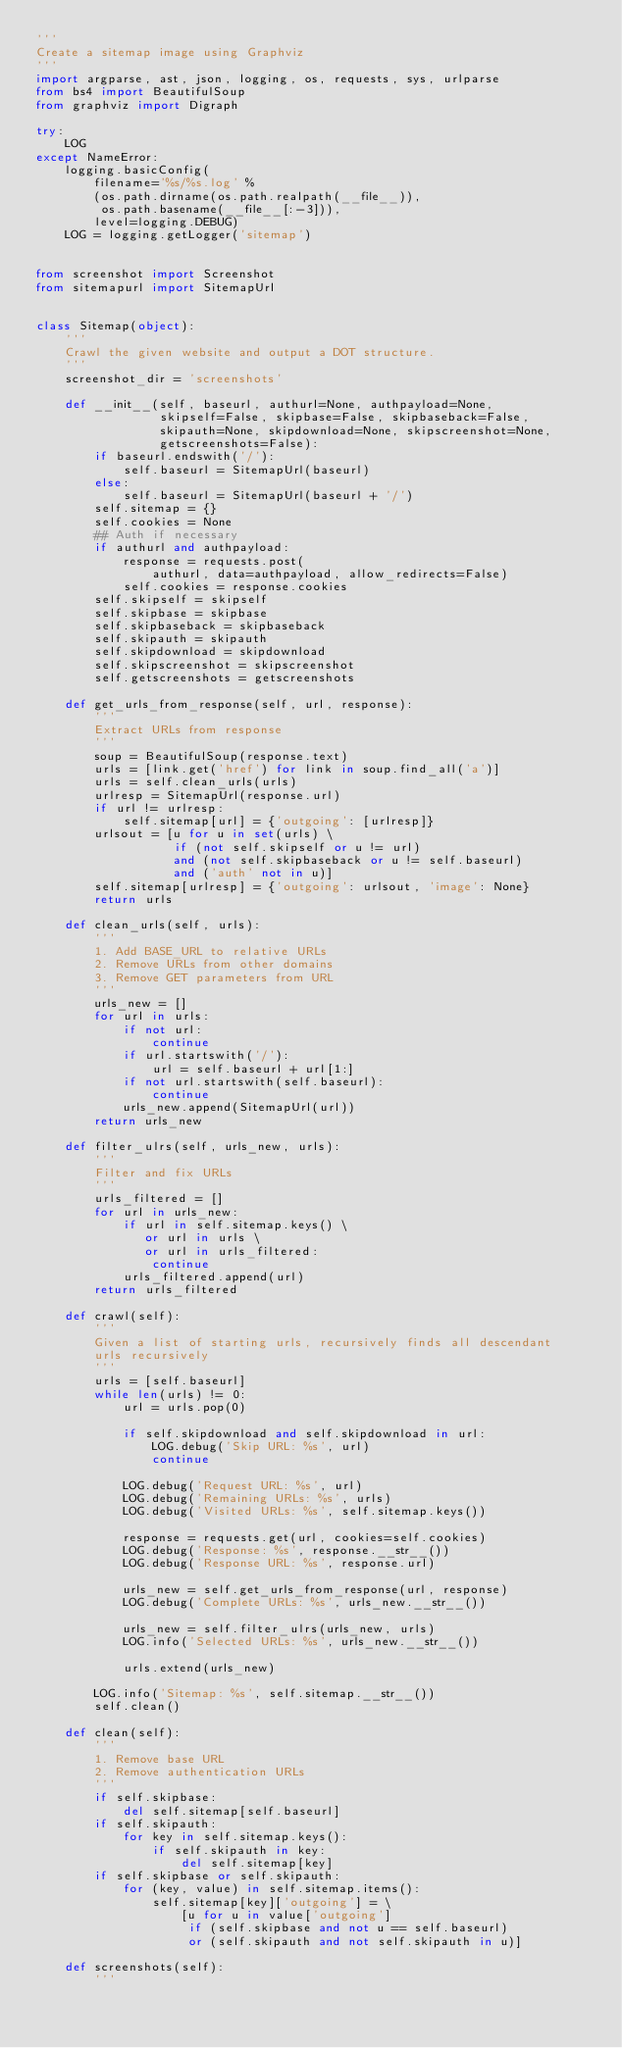Convert code to text. <code><loc_0><loc_0><loc_500><loc_500><_Python_>'''
Create a sitemap image using Graphviz
'''
import argparse, ast, json, logging, os, requests, sys, urlparse
from bs4 import BeautifulSoup
from graphviz import Digraph

try:
    LOG
except NameError:
    logging.basicConfig(
        filename='%s/%s.log' %
        (os.path.dirname(os.path.realpath(__file__)),
         os.path.basename(__file__[:-3])),
        level=logging.DEBUG)
    LOG = logging.getLogger('sitemap')


from screenshot import Screenshot
from sitemapurl import SitemapUrl


class Sitemap(object):
    '''
    Crawl the given website and output a DOT structure.
    '''
    screenshot_dir = 'screenshots'

    def __init__(self, baseurl, authurl=None, authpayload=None,
                 skipself=False, skipbase=False, skipbaseback=False,
                 skipauth=None, skipdownload=None, skipscreenshot=None,
                 getscreenshots=False):
        if baseurl.endswith('/'):
            self.baseurl = SitemapUrl(baseurl)
        else:
            self.baseurl = SitemapUrl(baseurl + '/')
        self.sitemap = {}
        self.cookies = None
        ## Auth if necessary
        if authurl and authpayload:
            response = requests.post(
                authurl, data=authpayload, allow_redirects=False)
            self.cookies = response.cookies
        self.skipself = skipself
        self.skipbase = skipbase
        self.skipbaseback = skipbaseback
        self.skipauth = skipauth
        self.skipdownload = skipdownload
        self.skipscreenshot = skipscreenshot
        self.getscreenshots = getscreenshots

    def get_urls_from_response(self, url, response):
        '''
        Extract URLs from response
        '''
        soup = BeautifulSoup(response.text)
        urls = [link.get('href') for link in soup.find_all('a')]
        urls = self.clean_urls(urls)
        urlresp = SitemapUrl(response.url)
        if url != urlresp:
            self.sitemap[url] = {'outgoing': [urlresp]}
        urlsout = [u for u in set(urls) \
                   if (not self.skipself or u != url)
                   and (not self.skipbaseback or u != self.baseurl)
                   and ('auth' not in u)]
        self.sitemap[urlresp] = {'outgoing': urlsout, 'image': None}
        return urls

    def clean_urls(self, urls):
        '''
        1. Add BASE_URL to relative URLs
        2. Remove URLs from other domains
        3. Remove GET parameters from URL
        '''
        urls_new = []
        for url in urls:
            if not url:
                continue
            if url.startswith('/'):
                url = self.baseurl + url[1:]
            if not url.startswith(self.baseurl):
                continue
            urls_new.append(SitemapUrl(url))
        return urls_new

    def filter_ulrs(self, urls_new, urls):
        '''
        Filter and fix URLs
        '''
        urls_filtered = []
        for url in urls_new:
            if url in self.sitemap.keys() \
               or url in urls \
               or url in urls_filtered:
                continue
            urls_filtered.append(url)
        return urls_filtered

    def crawl(self):
        '''
        Given a list of starting urls, recursively finds all descendant
        urls recursively
        '''
        urls = [self.baseurl]
        while len(urls) != 0:
            url = urls.pop(0)

            if self.skipdownload and self.skipdownload in url:
                LOG.debug('Skip URL: %s', url)
                continue

            LOG.debug('Request URL: %s', url)
            LOG.debug('Remaining URLs: %s', urls)
            LOG.debug('Visited URLs: %s', self.sitemap.keys())

            response = requests.get(url, cookies=self.cookies)
            LOG.debug('Response: %s', response.__str__())
            LOG.debug('Response URL: %s', response.url)

            urls_new = self.get_urls_from_response(url, response)
            LOG.debug('Complete URLs: %s', urls_new.__str__())

            urls_new = self.filter_ulrs(urls_new, urls)
            LOG.info('Selected URLs: %s', urls_new.__str__())

            urls.extend(urls_new)

        LOG.info('Sitemap: %s', self.sitemap.__str__())
        self.clean()

    def clean(self):
        '''
        1. Remove base URL
        2. Remove authentication URLs
        '''
        if self.skipbase:
            del self.sitemap[self.baseurl]
        if self.skipauth:
            for key in self.sitemap.keys():
                if self.skipauth in key:
                    del self.sitemap[key]
        if self.skipbase or self.skipauth:
            for (key, value) in self.sitemap.items():
                self.sitemap[key]['outgoing'] = \
                    [u for u in value['outgoing']
                     if (self.skipbase and not u == self.baseurl)
                     or (self.skipauth and not self.skipauth in u)]

    def screenshots(self):
        '''</code> 